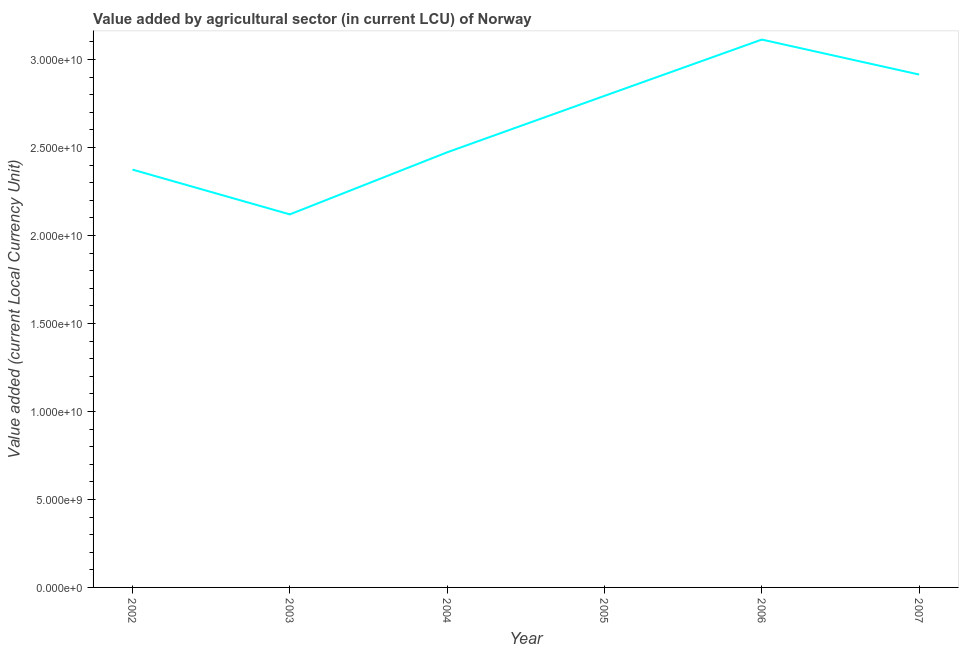What is the value added by agriculture sector in 2005?
Your response must be concise. 2.79e+1. Across all years, what is the maximum value added by agriculture sector?
Ensure brevity in your answer.  3.11e+1. Across all years, what is the minimum value added by agriculture sector?
Keep it short and to the point. 2.12e+1. In which year was the value added by agriculture sector maximum?
Your response must be concise. 2006. In which year was the value added by agriculture sector minimum?
Your answer should be compact. 2003. What is the sum of the value added by agriculture sector?
Keep it short and to the point. 1.58e+11. What is the difference between the value added by agriculture sector in 2002 and 2003?
Make the answer very short. 2.54e+09. What is the average value added by agriculture sector per year?
Give a very brief answer. 2.63e+1. What is the median value added by agriculture sector?
Keep it short and to the point. 2.63e+1. In how many years, is the value added by agriculture sector greater than 10000000000 LCU?
Your answer should be very brief. 6. What is the ratio of the value added by agriculture sector in 2004 to that in 2005?
Provide a succinct answer. 0.89. What is the difference between the highest and the second highest value added by agriculture sector?
Make the answer very short. 1.99e+09. Is the sum of the value added by agriculture sector in 2003 and 2004 greater than the maximum value added by agriculture sector across all years?
Ensure brevity in your answer.  Yes. What is the difference between the highest and the lowest value added by agriculture sector?
Make the answer very short. 9.93e+09. Does the value added by agriculture sector monotonically increase over the years?
Provide a succinct answer. No. How many lines are there?
Keep it short and to the point. 1. What is the difference between two consecutive major ticks on the Y-axis?
Offer a terse response. 5.00e+09. Are the values on the major ticks of Y-axis written in scientific E-notation?
Your answer should be very brief. Yes. Does the graph contain grids?
Make the answer very short. No. What is the title of the graph?
Your response must be concise. Value added by agricultural sector (in current LCU) of Norway. What is the label or title of the Y-axis?
Make the answer very short. Value added (current Local Currency Unit). What is the Value added (current Local Currency Unit) of 2002?
Keep it short and to the point. 2.37e+1. What is the Value added (current Local Currency Unit) of 2003?
Keep it short and to the point. 2.12e+1. What is the Value added (current Local Currency Unit) of 2004?
Your answer should be compact. 2.47e+1. What is the Value added (current Local Currency Unit) of 2005?
Provide a short and direct response. 2.79e+1. What is the Value added (current Local Currency Unit) in 2006?
Provide a short and direct response. 3.11e+1. What is the Value added (current Local Currency Unit) of 2007?
Your response must be concise. 2.91e+1. What is the difference between the Value added (current Local Currency Unit) in 2002 and 2003?
Provide a succinct answer. 2.54e+09. What is the difference between the Value added (current Local Currency Unit) in 2002 and 2004?
Make the answer very short. -9.82e+08. What is the difference between the Value added (current Local Currency Unit) in 2002 and 2005?
Keep it short and to the point. -4.19e+09. What is the difference between the Value added (current Local Currency Unit) in 2002 and 2006?
Offer a very short reply. -7.39e+09. What is the difference between the Value added (current Local Currency Unit) in 2002 and 2007?
Give a very brief answer. -5.40e+09. What is the difference between the Value added (current Local Currency Unit) in 2003 and 2004?
Offer a terse response. -3.53e+09. What is the difference between the Value added (current Local Currency Unit) in 2003 and 2005?
Your response must be concise. -6.73e+09. What is the difference between the Value added (current Local Currency Unit) in 2003 and 2006?
Your answer should be very brief. -9.93e+09. What is the difference between the Value added (current Local Currency Unit) in 2003 and 2007?
Keep it short and to the point. -7.94e+09. What is the difference between the Value added (current Local Currency Unit) in 2004 and 2005?
Make the answer very short. -3.21e+09. What is the difference between the Value added (current Local Currency Unit) in 2004 and 2006?
Offer a very short reply. -6.41e+09. What is the difference between the Value added (current Local Currency Unit) in 2004 and 2007?
Give a very brief answer. -4.42e+09. What is the difference between the Value added (current Local Currency Unit) in 2005 and 2006?
Offer a very short reply. -3.20e+09. What is the difference between the Value added (current Local Currency Unit) in 2005 and 2007?
Offer a very short reply. -1.21e+09. What is the difference between the Value added (current Local Currency Unit) in 2006 and 2007?
Your response must be concise. 1.99e+09. What is the ratio of the Value added (current Local Currency Unit) in 2002 to that in 2003?
Give a very brief answer. 1.12. What is the ratio of the Value added (current Local Currency Unit) in 2002 to that in 2004?
Provide a succinct answer. 0.96. What is the ratio of the Value added (current Local Currency Unit) in 2002 to that in 2006?
Make the answer very short. 0.76. What is the ratio of the Value added (current Local Currency Unit) in 2002 to that in 2007?
Your answer should be very brief. 0.81. What is the ratio of the Value added (current Local Currency Unit) in 2003 to that in 2004?
Offer a terse response. 0.86. What is the ratio of the Value added (current Local Currency Unit) in 2003 to that in 2005?
Your answer should be compact. 0.76. What is the ratio of the Value added (current Local Currency Unit) in 2003 to that in 2006?
Provide a succinct answer. 0.68. What is the ratio of the Value added (current Local Currency Unit) in 2003 to that in 2007?
Give a very brief answer. 0.73. What is the ratio of the Value added (current Local Currency Unit) in 2004 to that in 2005?
Offer a very short reply. 0.89. What is the ratio of the Value added (current Local Currency Unit) in 2004 to that in 2006?
Provide a short and direct response. 0.79. What is the ratio of the Value added (current Local Currency Unit) in 2004 to that in 2007?
Ensure brevity in your answer.  0.85. What is the ratio of the Value added (current Local Currency Unit) in 2005 to that in 2006?
Your answer should be very brief. 0.9. What is the ratio of the Value added (current Local Currency Unit) in 2005 to that in 2007?
Keep it short and to the point. 0.96. What is the ratio of the Value added (current Local Currency Unit) in 2006 to that in 2007?
Provide a succinct answer. 1.07. 